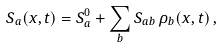Convert formula to latex. <formula><loc_0><loc_0><loc_500><loc_500>S _ { a } ( { x } , t ) = S _ { a } ^ { 0 } + \sum _ { b } S _ { a b } \, \rho _ { b } ( { x } , t ) \, ,</formula> 